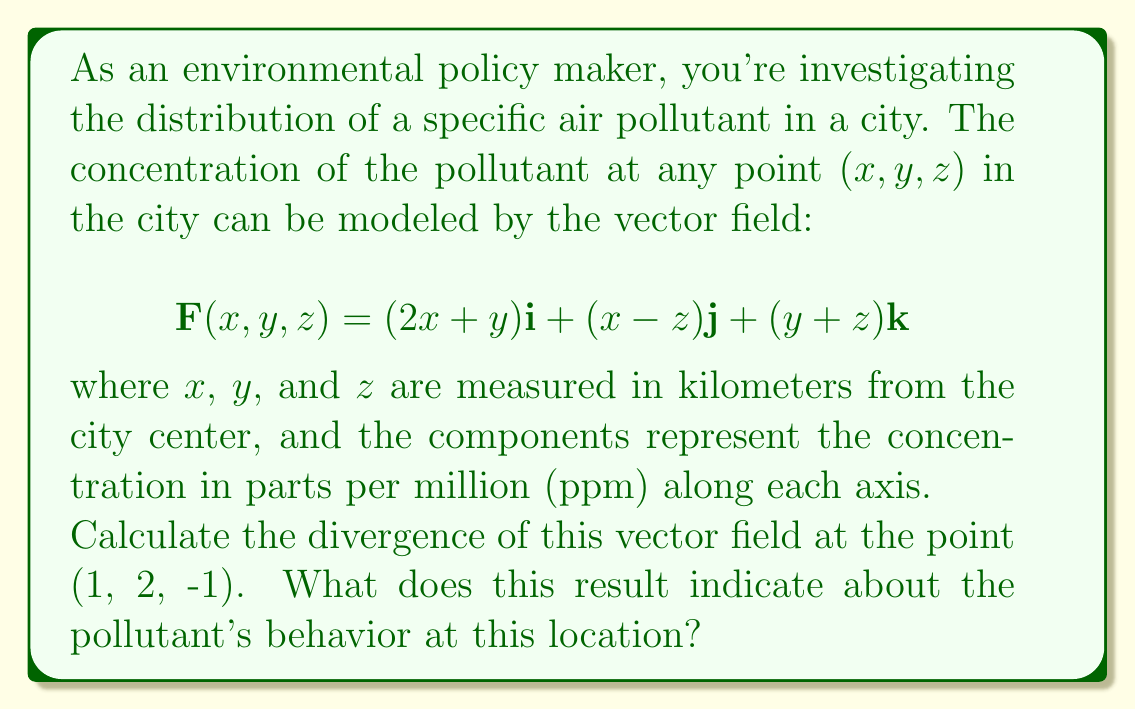Provide a solution to this math problem. To solve this problem, we need to calculate the divergence of the vector field at the given point. The divergence of a vector field $\mathbf{F}(x,y,z) = P\mathbf{i} + Q\mathbf{j} + R\mathbf{k}$ is given by:

$$\nabla \cdot \mathbf{F} = \frac{\partial P}{\partial x} + \frac{\partial Q}{\partial y} + \frac{\partial R}{\partial z}$$

For our vector field:
$P = 2x+y$
$Q = x-z$
$R = y+z$

Now, let's calculate each partial derivative:

1) $\frac{\partial P}{\partial x} = \frac{\partial}{\partial x}(2x+y) = 2$

2) $\frac{\partial Q}{\partial y} = \frac{\partial}{\partial y}(x-z) = 0$

3) $\frac{\partial R}{\partial z} = \frac{\partial}{\partial z}(y+z) = 1$

Therefore, the divergence is:

$$\nabla \cdot \mathbf{F} = 2 + 0 + 1 = 3$$

This result is constant and doesn't depend on the specific point. However, we were asked to evaluate it at (1, 2, -1), so we can confirm that the divergence at this point is indeed 3.

Interpretation: The positive divergence indicates that this point (1, 2, -1) is a source of the pollutant. This means that the pollutant concentration is increasing at this location, with more pollutant flowing outward than inward. The magnitude of 3 ppm/km suggests a significant rate of increase in pollutant concentration at this point.
Answer: The divergence of the vector field at the point (1, 2, -1) is 3 ppm/km, indicating that this location is a source of the pollutant with a significant rate of concentration increase. 